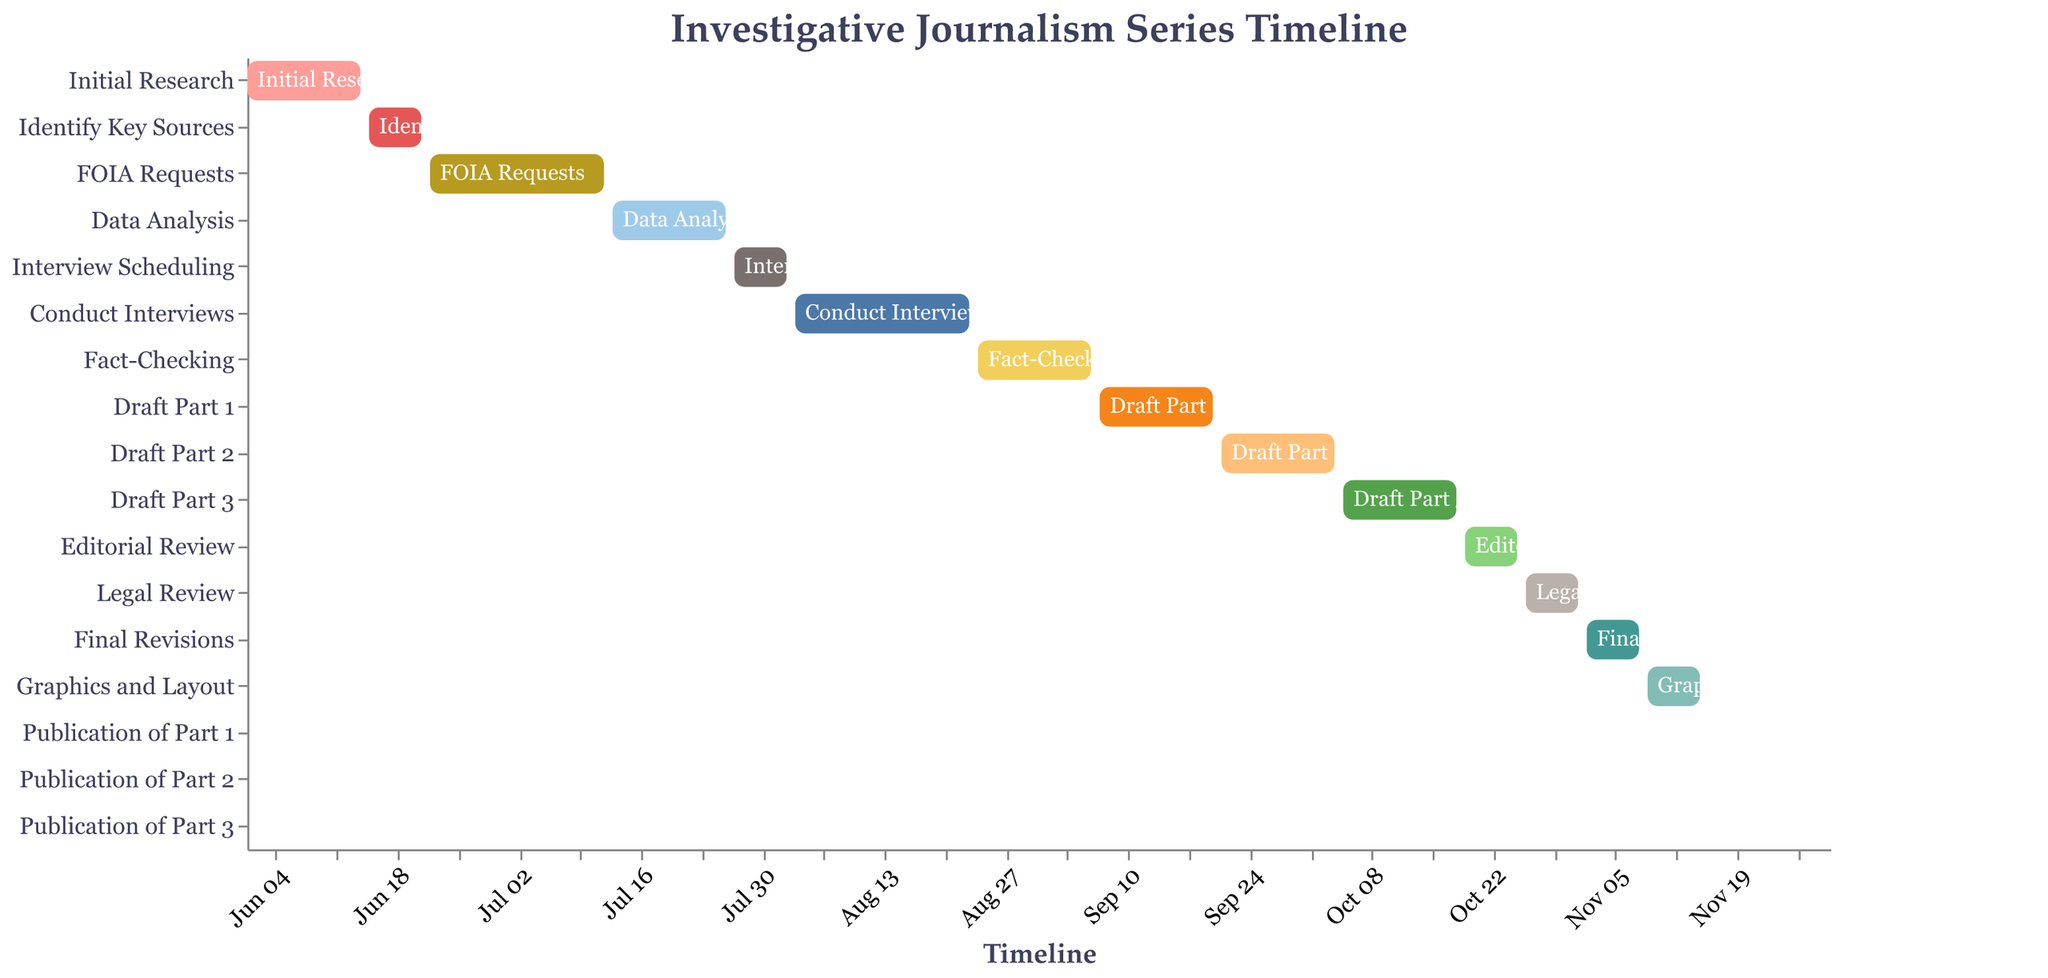What is the start date of the "Initial Research" phase? Look at the "Initial Research" bar and identify the starting point on the timeline axis.
Answer: June 1, 2023 When does the "Final Revisions" phase end? Identify the "Final Revisions" task and look at the end date of the corresponding bar.
Answer: November 8, 2023 Which task directly follows "Identify Key Sources"? Find "Identify Key Sources" and check the task that starts immediately after its end date.
Answer: FOIA Requests How long is the "Conduct Interviews" phase? Calculate the number of days between the start and end dates of the "Conduct Interviews" phase.
Answer: 21 days In which month does "FOIA Requests" end? Identify the end date of "FOIA Requests" and determine the month.
Answer: July How many phases involve writing drafts of different parts? Count the number of tasks that have the word "Draft" in their names.
Answer: 3 Which phase has the shortest duration? Compare the durations (end date - start date) of all tasks and identify the shortest one.
Answer: Each "Publication" task (1 day each) What is the combined duration of all phases that occur entirely in August? Sum the durations of phases within the timeframe of August 1 to August 31.
Answer: 30 days (Conduct Interviews 21 days + part of Fact-Checking 9 days) What tasks take place in November? Identify all tasks that have start or end dates in November.
Answer: Legal Review, Final Revisions, Graphics and Layout, Publications When does the "Editorial Review" phase start? Identify the "Editorial Review" task and look at its starting point on the timeline axis.
Answer: October 19, 2023 